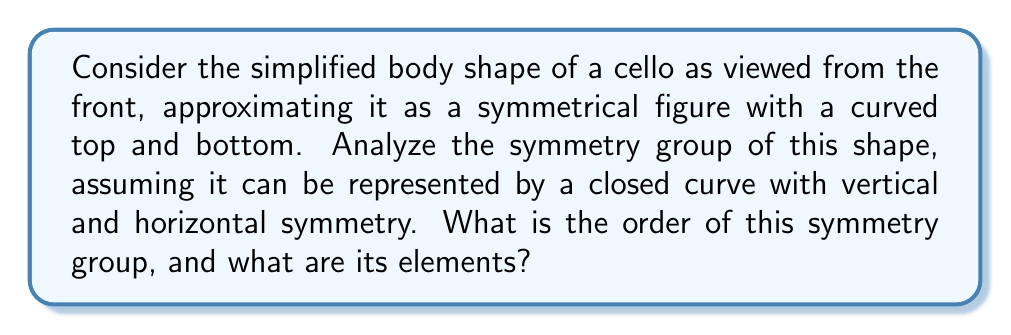Can you answer this question? To analyze the symmetry group of the cello's body shape, we'll follow these steps:

1) First, let's identify the symmetries of the cello's body shape:
   - Reflection across the vertical axis (top to bottom)
   - Reflection across the horizontal axis (left to right)
   - 180° rotation around the center
   - Identity transformation (no change)

2) These symmetries form a group under composition. Let's denote them as:
   $e$ : identity
   $r_v$ : vertical reflection
   $r_h$ : horizontal reflection
   $r_{180}$ : 180° rotation

3) We can verify that these form a group:
   - Closure: Composing any two of these symmetries results in another symmetry in the set.
   - Associativity: Composition of functions is always associative.
   - Identity: $e$ is the identity element.
   - Inverse: Each element is its own inverse (i.e., performing any symmetry twice returns to the original state).

4) To determine the structure of this group, let's create its Cayley table:

   $$\begin{array}{c|cccc}
   \circ & e & r_v & r_h & r_{180} \\
   \hline
   e & e & r_v & r_h & r_{180} \\
   r_v & r_v & e & r_{180} & r_h \\
   r_h & r_h & r_{180} & e & r_v \\
   r_{180} & r_{180} & r_h & r_v & e
   \end{array}$$

5) From this table, we can see that:
   - The group has 4 elements
   - $(r_v)^2 = (r_h)^2 = (r_{180})^2 = e$
   - $r_v \circ r_h = r_h \circ r_v = r_{180}$

6) This structure is isomorphic to the Klein four-group, also known as $V_4$ or $C_2 \times C_2$.
Answer: The symmetry group of the simplified cello body shape has order 4. Its elements are $\{e, r_v, r_h, r_{180}\}$, where $e$ is the identity, $r_v$ is vertical reflection, $r_h$ is horizontal reflection, and $r_{180}$ is 180° rotation. This group is isomorphic to the Klein four-group ($V_4$). 